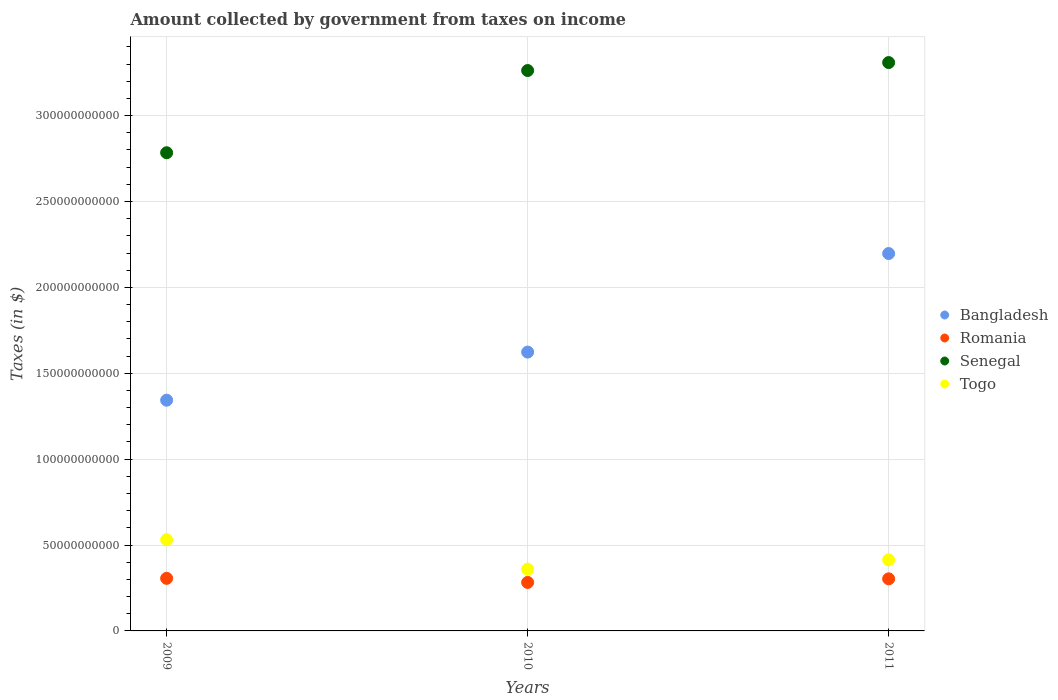How many different coloured dotlines are there?
Keep it short and to the point. 4. Is the number of dotlines equal to the number of legend labels?
Offer a very short reply. Yes. What is the amount collected by government from taxes on income in Togo in 2009?
Offer a terse response. 5.31e+1. Across all years, what is the maximum amount collected by government from taxes on income in Togo?
Keep it short and to the point. 5.31e+1. Across all years, what is the minimum amount collected by government from taxes on income in Romania?
Your response must be concise. 2.82e+1. In which year was the amount collected by government from taxes on income in Togo minimum?
Your answer should be very brief. 2010. What is the total amount collected by government from taxes on income in Bangladesh in the graph?
Offer a terse response. 5.16e+11. What is the difference between the amount collected by government from taxes on income in Romania in 2009 and that in 2010?
Offer a very short reply. 2.37e+09. What is the difference between the amount collected by government from taxes on income in Senegal in 2011 and the amount collected by government from taxes on income in Romania in 2009?
Give a very brief answer. 3.00e+11. What is the average amount collected by government from taxes on income in Togo per year?
Make the answer very short. 4.35e+1. In the year 2010, what is the difference between the amount collected by government from taxes on income in Romania and amount collected by government from taxes on income in Senegal?
Ensure brevity in your answer.  -2.98e+11. What is the ratio of the amount collected by government from taxes on income in Togo in 2010 to that in 2011?
Offer a very short reply. 0.87. What is the difference between the highest and the second highest amount collected by government from taxes on income in Senegal?
Ensure brevity in your answer.  4.64e+09. What is the difference between the highest and the lowest amount collected by government from taxes on income in Romania?
Give a very brief answer. 2.37e+09. Is it the case that in every year, the sum of the amount collected by government from taxes on income in Bangladesh and amount collected by government from taxes on income in Romania  is greater than the amount collected by government from taxes on income in Senegal?
Your answer should be compact. No. Is the amount collected by government from taxes on income in Bangladesh strictly greater than the amount collected by government from taxes on income in Togo over the years?
Make the answer very short. Yes. How many years are there in the graph?
Provide a short and direct response. 3. Where does the legend appear in the graph?
Offer a very short reply. Center right. How many legend labels are there?
Offer a terse response. 4. How are the legend labels stacked?
Give a very brief answer. Vertical. What is the title of the graph?
Your answer should be very brief. Amount collected by government from taxes on income. Does "Yemen, Rep." appear as one of the legend labels in the graph?
Ensure brevity in your answer.  No. What is the label or title of the X-axis?
Give a very brief answer. Years. What is the label or title of the Y-axis?
Offer a terse response. Taxes (in $). What is the Taxes (in $) of Bangladesh in 2009?
Provide a succinct answer. 1.34e+11. What is the Taxes (in $) in Romania in 2009?
Give a very brief answer. 3.06e+1. What is the Taxes (in $) in Senegal in 2009?
Your response must be concise. 2.78e+11. What is the Taxes (in $) of Togo in 2009?
Offer a very short reply. 5.31e+1. What is the Taxes (in $) of Bangladesh in 2010?
Provide a short and direct response. 1.62e+11. What is the Taxes (in $) in Romania in 2010?
Your response must be concise. 2.82e+1. What is the Taxes (in $) in Senegal in 2010?
Ensure brevity in your answer.  3.26e+11. What is the Taxes (in $) in Togo in 2010?
Your response must be concise. 3.60e+1. What is the Taxes (in $) of Bangladesh in 2011?
Provide a succinct answer. 2.20e+11. What is the Taxes (in $) of Romania in 2011?
Ensure brevity in your answer.  3.03e+1. What is the Taxes (in $) in Senegal in 2011?
Your answer should be compact. 3.31e+11. What is the Taxes (in $) in Togo in 2011?
Your answer should be compact. 4.14e+1. Across all years, what is the maximum Taxes (in $) in Bangladesh?
Provide a short and direct response. 2.20e+11. Across all years, what is the maximum Taxes (in $) of Romania?
Ensure brevity in your answer.  3.06e+1. Across all years, what is the maximum Taxes (in $) in Senegal?
Provide a succinct answer. 3.31e+11. Across all years, what is the maximum Taxes (in $) in Togo?
Provide a succinct answer. 5.31e+1. Across all years, what is the minimum Taxes (in $) of Bangladesh?
Keep it short and to the point. 1.34e+11. Across all years, what is the minimum Taxes (in $) of Romania?
Keep it short and to the point. 2.82e+1. Across all years, what is the minimum Taxes (in $) in Senegal?
Your answer should be compact. 2.78e+11. Across all years, what is the minimum Taxes (in $) of Togo?
Your answer should be very brief. 3.60e+1. What is the total Taxes (in $) in Bangladesh in the graph?
Provide a short and direct response. 5.16e+11. What is the total Taxes (in $) in Romania in the graph?
Ensure brevity in your answer.  8.92e+1. What is the total Taxes (in $) of Senegal in the graph?
Your answer should be compact. 9.36e+11. What is the total Taxes (in $) in Togo in the graph?
Your answer should be very brief. 1.30e+11. What is the difference between the Taxes (in $) of Bangladesh in 2009 and that in 2010?
Your answer should be very brief. -2.80e+1. What is the difference between the Taxes (in $) in Romania in 2009 and that in 2010?
Provide a succinct answer. 2.37e+09. What is the difference between the Taxes (in $) in Senegal in 2009 and that in 2010?
Make the answer very short. -4.79e+1. What is the difference between the Taxes (in $) of Togo in 2009 and that in 2010?
Your answer should be very brief. 1.71e+1. What is the difference between the Taxes (in $) in Bangladesh in 2009 and that in 2011?
Your answer should be very brief. -8.54e+1. What is the difference between the Taxes (in $) of Romania in 2009 and that in 2011?
Your answer should be compact. 2.83e+08. What is the difference between the Taxes (in $) of Senegal in 2009 and that in 2011?
Your response must be concise. -5.25e+1. What is the difference between the Taxes (in $) in Togo in 2009 and that in 2011?
Your response must be concise. 1.17e+1. What is the difference between the Taxes (in $) in Bangladesh in 2010 and that in 2011?
Your answer should be compact. -5.74e+1. What is the difference between the Taxes (in $) of Romania in 2010 and that in 2011?
Your response must be concise. -2.09e+09. What is the difference between the Taxes (in $) in Senegal in 2010 and that in 2011?
Provide a succinct answer. -4.64e+09. What is the difference between the Taxes (in $) in Togo in 2010 and that in 2011?
Make the answer very short. -5.41e+09. What is the difference between the Taxes (in $) in Bangladesh in 2009 and the Taxes (in $) in Romania in 2010?
Provide a succinct answer. 1.06e+11. What is the difference between the Taxes (in $) in Bangladesh in 2009 and the Taxes (in $) in Senegal in 2010?
Keep it short and to the point. -1.92e+11. What is the difference between the Taxes (in $) of Bangladesh in 2009 and the Taxes (in $) of Togo in 2010?
Give a very brief answer. 9.84e+1. What is the difference between the Taxes (in $) of Romania in 2009 and the Taxes (in $) of Senegal in 2010?
Your answer should be very brief. -2.96e+11. What is the difference between the Taxes (in $) of Romania in 2009 and the Taxes (in $) of Togo in 2010?
Make the answer very short. -5.36e+09. What is the difference between the Taxes (in $) in Senegal in 2009 and the Taxes (in $) in Togo in 2010?
Offer a very short reply. 2.42e+11. What is the difference between the Taxes (in $) in Bangladesh in 2009 and the Taxes (in $) in Romania in 2011?
Your response must be concise. 1.04e+11. What is the difference between the Taxes (in $) in Bangladesh in 2009 and the Taxes (in $) in Senegal in 2011?
Your answer should be very brief. -1.97e+11. What is the difference between the Taxes (in $) of Bangladesh in 2009 and the Taxes (in $) of Togo in 2011?
Make the answer very short. 9.30e+1. What is the difference between the Taxes (in $) of Romania in 2009 and the Taxes (in $) of Senegal in 2011?
Your response must be concise. -3.00e+11. What is the difference between the Taxes (in $) in Romania in 2009 and the Taxes (in $) in Togo in 2011?
Your response must be concise. -1.08e+1. What is the difference between the Taxes (in $) in Senegal in 2009 and the Taxes (in $) in Togo in 2011?
Your answer should be very brief. 2.37e+11. What is the difference between the Taxes (in $) in Bangladesh in 2010 and the Taxes (in $) in Romania in 2011?
Your response must be concise. 1.32e+11. What is the difference between the Taxes (in $) in Bangladesh in 2010 and the Taxes (in $) in Senegal in 2011?
Offer a terse response. -1.69e+11. What is the difference between the Taxes (in $) of Bangladesh in 2010 and the Taxes (in $) of Togo in 2011?
Offer a very short reply. 1.21e+11. What is the difference between the Taxes (in $) of Romania in 2010 and the Taxes (in $) of Senegal in 2011?
Give a very brief answer. -3.03e+11. What is the difference between the Taxes (in $) in Romania in 2010 and the Taxes (in $) in Togo in 2011?
Offer a very short reply. -1.31e+1. What is the difference between the Taxes (in $) in Senegal in 2010 and the Taxes (in $) in Togo in 2011?
Provide a short and direct response. 2.85e+11. What is the average Taxes (in $) in Bangladesh per year?
Offer a very short reply. 1.72e+11. What is the average Taxes (in $) of Romania per year?
Make the answer very short. 2.97e+1. What is the average Taxes (in $) of Senegal per year?
Provide a succinct answer. 3.12e+11. What is the average Taxes (in $) in Togo per year?
Keep it short and to the point. 4.35e+1. In the year 2009, what is the difference between the Taxes (in $) of Bangladesh and Taxes (in $) of Romania?
Offer a terse response. 1.04e+11. In the year 2009, what is the difference between the Taxes (in $) in Bangladesh and Taxes (in $) in Senegal?
Provide a short and direct response. -1.44e+11. In the year 2009, what is the difference between the Taxes (in $) in Bangladesh and Taxes (in $) in Togo?
Provide a short and direct response. 8.12e+1. In the year 2009, what is the difference between the Taxes (in $) in Romania and Taxes (in $) in Senegal?
Offer a terse response. -2.48e+11. In the year 2009, what is the difference between the Taxes (in $) of Romania and Taxes (in $) of Togo?
Keep it short and to the point. -2.25e+1. In the year 2009, what is the difference between the Taxes (in $) of Senegal and Taxes (in $) of Togo?
Your answer should be very brief. 2.25e+11. In the year 2010, what is the difference between the Taxes (in $) in Bangladesh and Taxes (in $) in Romania?
Provide a succinct answer. 1.34e+11. In the year 2010, what is the difference between the Taxes (in $) of Bangladesh and Taxes (in $) of Senegal?
Your answer should be compact. -1.64e+11. In the year 2010, what is the difference between the Taxes (in $) of Bangladesh and Taxes (in $) of Togo?
Your answer should be compact. 1.26e+11. In the year 2010, what is the difference between the Taxes (in $) in Romania and Taxes (in $) in Senegal?
Keep it short and to the point. -2.98e+11. In the year 2010, what is the difference between the Taxes (in $) of Romania and Taxes (in $) of Togo?
Provide a succinct answer. -7.73e+09. In the year 2010, what is the difference between the Taxes (in $) of Senegal and Taxes (in $) of Togo?
Your answer should be very brief. 2.90e+11. In the year 2011, what is the difference between the Taxes (in $) of Bangladesh and Taxes (in $) of Romania?
Offer a terse response. 1.89e+11. In the year 2011, what is the difference between the Taxes (in $) of Bangladesh and Taxes (in $) of Senegal?
Provide a short and direct response. -1.11e+11. In the year 2011, what is the difference between the Taxes (in $) of Bangladesh and Taxes (in $) of Togo?
Offer a terse response. 1.78e+11. In the year 2011, what is the difference between the Taxes (in $) of Romania and Taxes (in $) of Senegal?
Provide a short and direct response. -3.01e+11. In the year 2011, what is the difference between the Taxes (in $) of Romania and Taxes (in $) of Togo?
Ensure brevity in your answer.  -1.11e+1. In the year 2011, what is the difference between the Taxes (in $) of Senegal and Taxes (in $) of Togo?
Provide a short and direct response. 2.90e+11. What is the ratio of the Taxes (in $) in Bangladesh in 2009 to that in 2010?
Your answer should be compact. 0.83. What is the ratio of the Taxes (in $) of Romania in 2009 to that in 2010?
Offer a very short reply. 1.08. What is the ratio of the Taxes (in $) in Senegal in 2009 to that in 2010?
Provide a short and direct response. 0.85. What is the ratio of the Taxes (in $) of Togo in 2009 to that in 2010?
Offer a terse response. 1.48. What is the ratio of the Taxes (in $) of Bangladesh in 2009 to that in 2011?
Offer a very short reply. 0.61. What is the ratio of the Taxes (in $) in Romania in 2009 to that in 2011?
Offer a terse response. 1.01. What is the ratio of the Taxes (in $) of Senegal in 2009 to that in 2011?
Your response must be concise. 0.84. What is the ratio of the Taxes (in $) of Togo in 2009 to that in 2011?
Your answer should be compact. 1.28. What is the ratio of the Taxes (in $) of Bangladesh in 2010 to that in 2011?
Provide a succinct answer. 0.74. What is the ratio of the Taxes (in $) of Romania in 2010 to that in 2011?
Provide a short and direct response. 0.93. What is the ratio of the Taxes (in $) in Senegal in 2010 to that in 2011?
Provide a succinct answer. 0.99. What is the ratio of the Taxes (in $) of Togo in 2010 to that in 2011?
Ensure brevity in your answer.  0.87. What is the difference between the highest and the second highest Taxes (in $) in Bangladesh?
Make the answer very short. 5.74e+1. What is the difference between the highest and the second highest Taxes (in $) of Romania?
Ensure brevity in your answer.  2.83e+08. What is the difference between the highest and the second highest Taxes (in $) of Senegal?
Give a very brief answer. 4.64e+09. What is the difference between the highest and the second highest Taxes (in $) in Togo?
Give a very brief answer. 1.17e+1. What is the difference between the highest and the lowest Taxes (in $) in Bangladesh?
Offer a very short reply. 8.54e+1. What is the difference between the highest and the lowest Taxes (in $) in Romania?
Provide a short and direct response. 2.37e+09. What is the difference between the highest and the lowest Taxes (in $) in Senegal?
Offer a very short reply. 5.25e+1. What is the difference between the highest and the lowest Taxes (in $) of Togo?
Ensure brevity in your answer.  1.71e+1. 